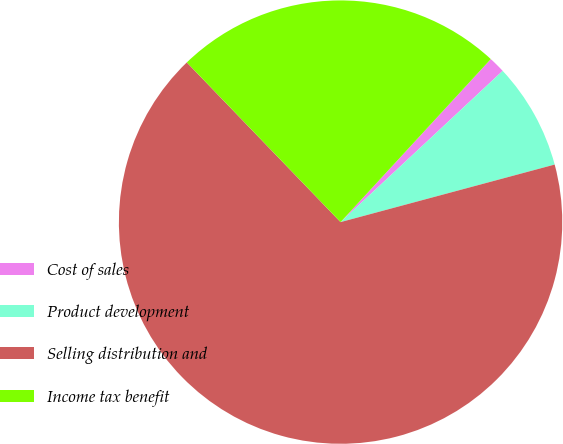Convert chart to OTSL. <chart><loc_0><loc_0><loc_500><loc_500><pie_chart><fcel>Cost of sales<fcel>Product development<fcel>Selling distribution and<fcel>Income tax benefit<nl><fcel>1.2%<fcel>7.77%<fcel>66.98%<fcel>24.05%<nl></chart> 